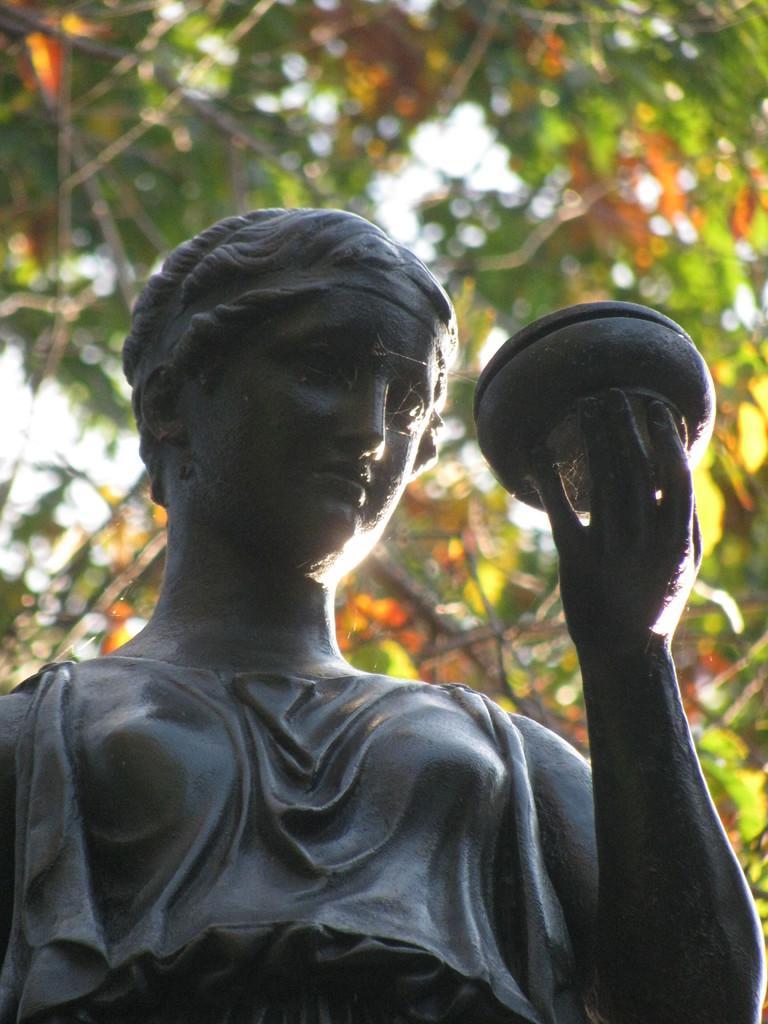Please provide a concise description of this image. In this image there is a statue in the middle. At the top there are leaves. The statue is holding the bowl. 